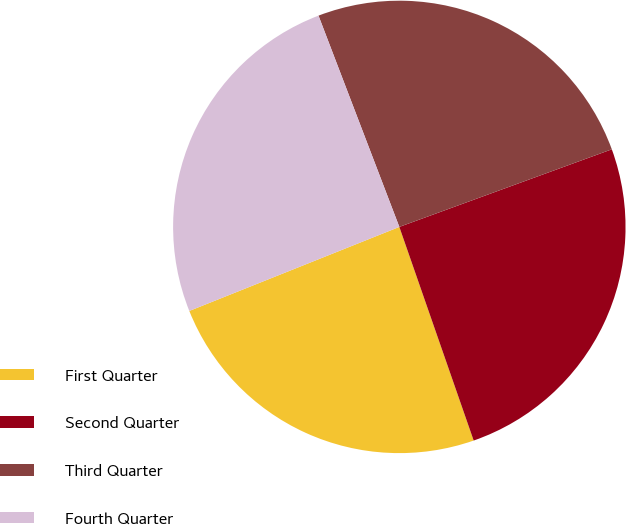<chart> <loc_0><loc_0><loc_500><loc_500><pie_chart><fcel>First Quarter<fcel>Second Quarter<fcel>Third Quarter<fcel>Fourth Quarter<nl><fcel>24.27%<fcel>25.24%<fcel>25.24%<fcel>25.24%<nl></chart> 